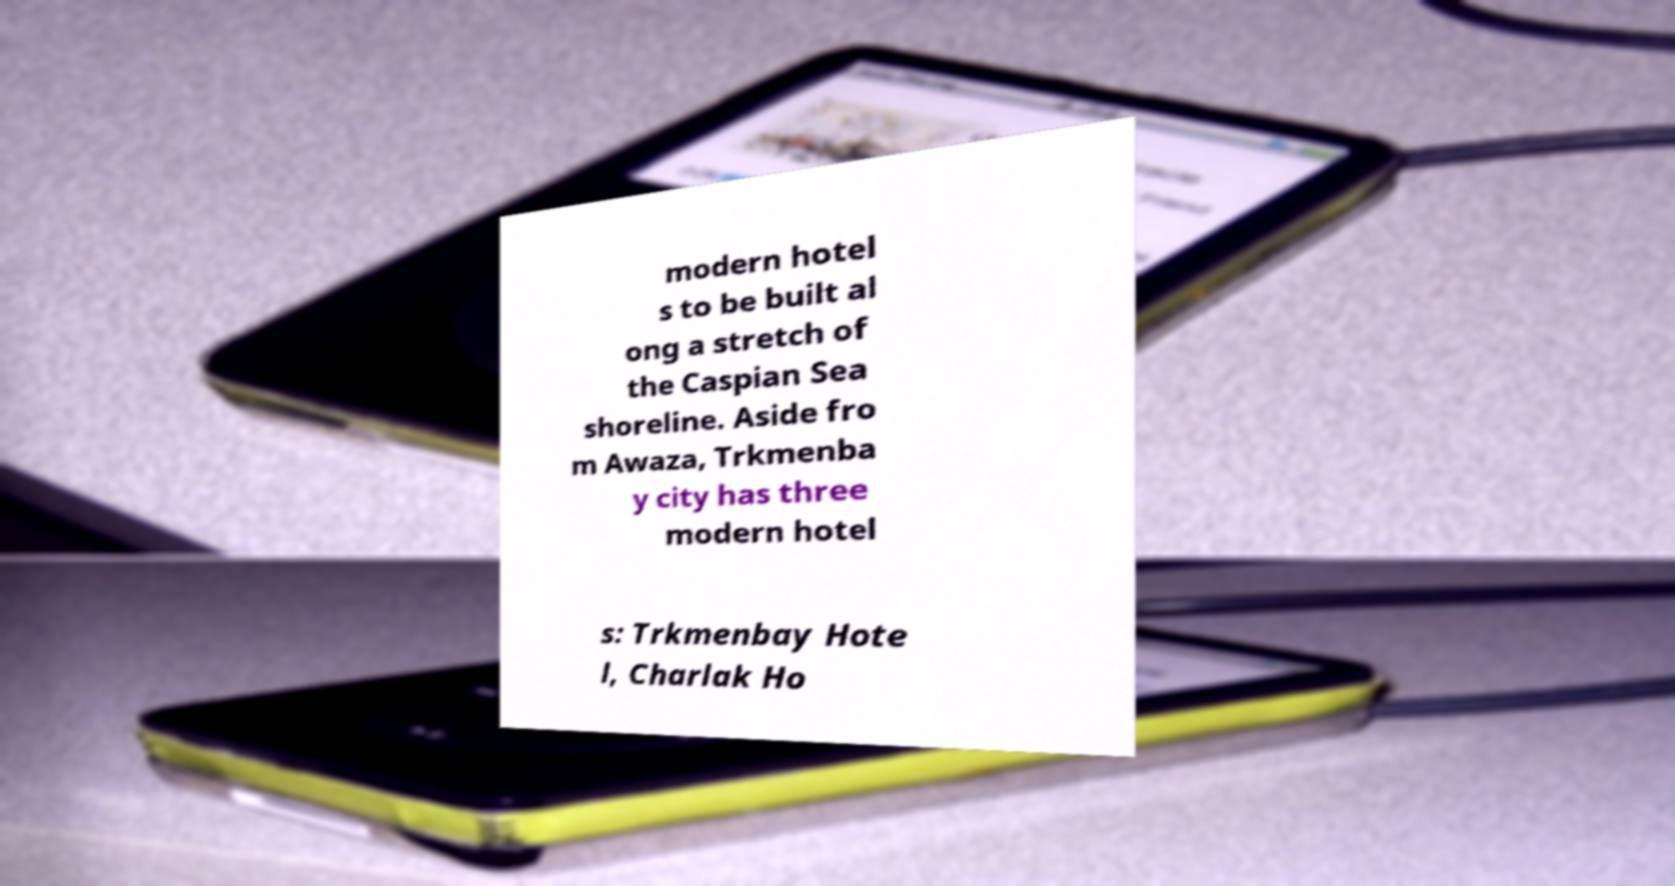Could you extract and type out the text from this image? modern hotel s to be built al ong a stretch of the Caspian Sea shoreline. Aside fro m Awaza, Trkmenba y city has three modern hotel s: Trkmenbay Hote l, Charlak Ho 